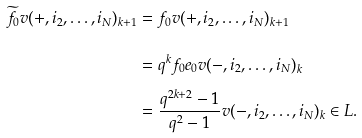<formula> <loc_0><loc_0><loc_500><loc_500>\widetilde { f _ { 0 } } v ( + , i _ { 2 } , \dots , i _ { N } ) _ { k + 1 } & = f _ { 0 } v ( + , i _ { 2 } , \dots , i _ { N } ) _ { k + 1 } \\ & = q ^ { k } f _ { 0 } e _ { 0 } v ( - , i _ { 2 } , \dots , i _ { N } ) _ { k } \\ & = \frac { q ^ { 2 k + 2 } - 1 } { q ^ { 2 } - 1 } v ( - , i _ { 2 } , \dots , i _ { N } ) _ { k } \in L .</formula> 